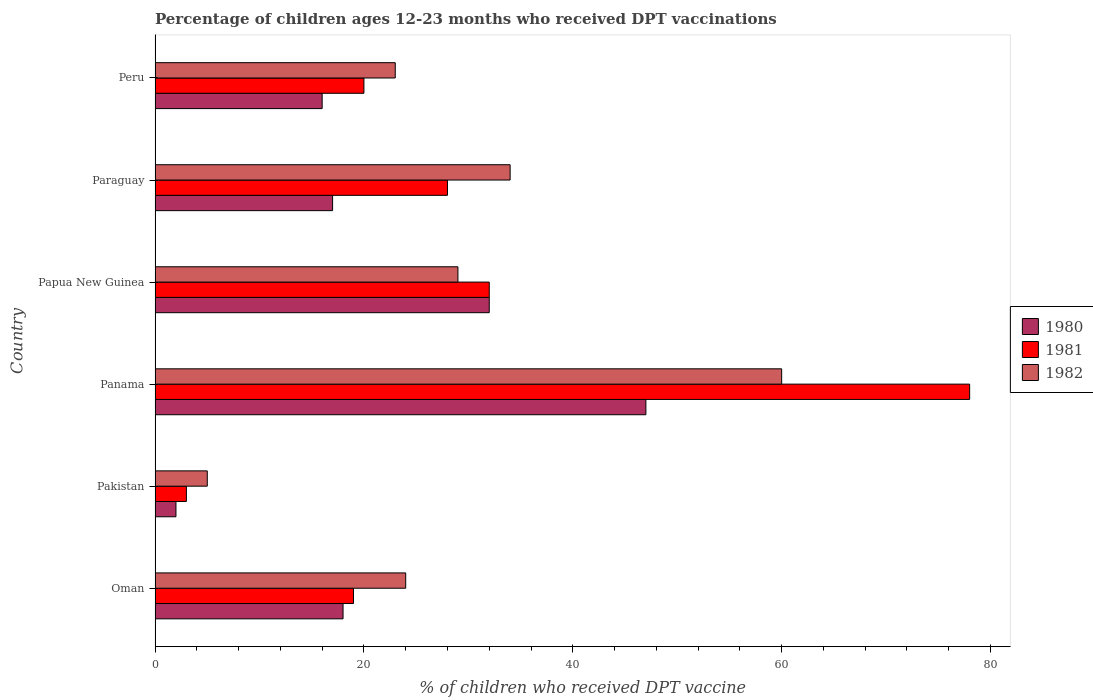How many groups of bars are there?
Provide a short and direct response. 6. Are the number of bars per tick equal to the number of legend labels?
Your answer should be compact. Yes. Are the number of bars on each tick of the Y-axis equal?
Your answer should be very brief. Yes. How many bars are there on the 4th tick from the top?
Offer a terse response. 3. What is the label of the 3rd group of bars from the top?
Give a very brief answer. Papua New Guinea. In how many cases, is the number of bars for a given country not equal to the number of legend labels?
Give a very brief answer. 0. Across all countries, what is the minimum percentage of children who received DPT vaccination in 1981?
Keep it short and to the point. 3. In which country was the percentage of children who received DPT vaccination in 1981 maximum?
Ensure brevity in your answer.  Panama. What is the total percentage of children who received DPT vaccination in 1982 in the graph?
Offer a terse response. 175. What is the difference between the percentage of children who received DPT vaccination in 1981 in Papua New Guinea and that in Peru?
Offer a very short reply. 12. In how many countries, is the percentage of children who received DPT vaccination in 1981 greater than 72 %?
Offer a very short reply. 1. What is the ratio of the percentage of children who received DPT vaccination in 1982 in Pakistan to that in Paraguay?
Your answer should be very brief. 0.15. Is the percentage of children who received DPT vaccination in 1982 in Papua New Guinea less than that in Peru?
Your response must be concise. No. Is the sum of the percentage of children who received DPT vaccination in 1981 in Oman and Peru greater than the maximum percentage of children who received DPT vaccination in 1980 across all countries?
Keep it short and to the point. No. How many countries are there in the graph?
Make the answer very short. 6. Does the graph contain any zero values?
Ensure brevity in your answer.  No. Does the graph contain grids?
Provide a short and direct response. No. How are the legend labels stacked?
Provide a short and direct response. Vertical. What is the title of the graph?
Keep it short and to the point. Percentage of children ages 12-23 months who received DPT vaccinations. Does "1986" appear as one of the legend labels in the graph?
Offer a terse response. No. What is the label or title of the X-axis?
Offer a very short reply. % of children who received DPT vaccine. What is the label or title of the Y-axis?
Ensure brevity in your answer.  Country. What is the % of children who received DPT vaccine in 1981 in Oman?
Give a very brief answer. 19. What is the % of children who received DPT vaccine of 1982 in Oman?
Ensure brevity in your answer.  24. What is the % of children who received DPT vaccine of 1980 in Pakistan?
Ensure brevity in your answer.  2. What is the % of children who received DPT vaccine in 1981 in Pakistan?
Provide a short and direct response. 3. What is the % of children who received DPT vaccine in 1981 in Panama?
Make the answer very short. 78. What is the % of children who received DPT vaccine in 1980 in Papua New Guinea?
Your response must be concise. 32. What is the % of children who received DPT vaccine in 1982 in Papua New Guinea?
Offer a terse response. 29. What is the % of children who received DPT vaccine of 1982 in Paraguay?
Ensure brevity in your answer.  34. What is the % of children who received DPT vaccine in 1981 in Peru?
Your answer should be compact. 20. Across all countries, what is the maximum % of children who received DPT vaccine in 1980?
Offer a terse response. 47. Across all countries, what is the maximum % of children who received DPT vaccine of 1982?
Give a very brief answer. 60. What is the total % of children who received DPT vaccine in 1980 in the graph?
Offer a very short reply. 132. What is the total % of children who received DPT vaccine in 1981 in the graph?
Make the answer very short. 180. What is the total % of children who received DPT vaccine of 1982 in the graph?
Give a very brief answer. 175. What is the difference between the % of children who received DPT vaccine of 1982 in Oman and that in Pakistan?
Make the answer very short. 19. What is the difference between the % of children who received DPT vaccine of 1980 in Oman and that in Panama?
Make the answer very short. -29. What is the difference between the % of children who received DPT vaccine in 1981 in Oman and that in Panama?
Ensure brevity in your answer.  -59. What is the difference between the % of children who received DPT vaccine of 1982 in Oman and that in Panama?
Offer a terse response. -36. What is the difference between the % of children who received DPT vaccine in 1981 in Oman and that in Papua New Guinea?
Offer a very short reply. -13. What is the difference between the % of children who received DPT vaccine in 1982 in Oman and that in Papua New Guinea?
Offer a terse response. -5. What is the difference between the % of children who received DPT vaccine in 1981 in Oman and that in Paraguay?
Offer a terse response. -9. What is the difference between the % of children who received DPT vaccine in 1982 in Oman and that in Paraguay?
Provide a short and direct response. -10. What is the difference between the % of children who received DPT vaccine of 1980 in Oman and that in Peru?
Make the answer very short. 2. What is the difference between the % of children who received DPT vaccine of 1981 in Oman and that in Peru?
Your answer should be compact. -1. What is the difference between the % of children who received DPT vaccine of 1980 in Pakistan and that in Panama?
Provide a succinct answer. -45. What is the difference between the % of children who received DPT vaccine in 1981 in Pakistan and that in Panama?
Make the answer very short. -75. What is the difference between the % of children who received DPT vaccine of 1982 in Pakistan and that in Panama?
Give a very brief answer. -55. What is the difference between the % of children who received DPT vaccine in 1981 in Pakistan and that in Papua New Guinea?
Your response must be concise. -29. What is the difference between the % of children who received DPT vaccine in 1982 in Pakistan and that in Papua New Guinea?
Your answer should be very brief. -24. What is the difference between the % of children who received DPT vaccine of 1980 in Pakistan and that in Paraguay?
Offer a very short reply. -15. What is the difference between the % of children who received DPT vaccine in 1981 in Pakistan and that in Paraguay?
Provide a succinct answer. -25. What is the difference between the % of children who received DPT vaccine of 1982 in Pakistan and that in Paraguay?
Your response must be concise. -29. What is the difference between the % of children who received DPT vaccine of 1982 in Pakistan and that in Peru?
Provide a short and direct response. -18. What is the difference between the % of children who received DPT vaccine in 1980 in Panama and that in Papua New Guinea?
Offer a terse response. 15. What is the difference between the % of children who received DPT vaccine of 1981 in Panama and that in Peru?
Ensure brevity in your answer.  58. What is the difference between the % of children who received DPT vaccine in 1982 in Panama and that in Peru?
Keep it short and to the point. 37. What is the difference between the % of children who received DPT vaccine in 1980 in Papua New Guinea and that in Paraguay?
Offer a very short reply. 15. What is the difference between the % of children who received DPT vaccine in 1982 in Papua New Guinea and that in Paraguay?
Give a very brief answer. -5. What is the difference between the % of children who received DPT vaccine in 1981 in Papua New Guinea and that in Peru?
Provide a succinct answer. 12. What is the difference between the % of children who received DPT vaccine of 1982 in Papua New Guinea and that in Peru?
Provide a short and direct response. 6. What is the difference between the % of children who received DPT vaccine in 1980 in Paraguay and that in Peru?
Offer a terse response. 1. What is the difference between the % of children who received DPT vaccine in 1981 in Paraguay and that in Peru?
Provide a succinct answer. 8. What is the difference between the % of children who received DPT vaccine of 1981 in Oman and the % of children who received DPT vaccine of 1982 in Pakistan?
Offer a terse response. 14. What is the difference between the % of children who received DPT vaccine of 1980 in Oman and the % of children who received DPT vaccine of 1981 in Panama?
Offer a very short reply. -60. What is the difference between the % of children who received DPT vaccine in 1980 in Oman and the % of children who received DPT vaccine in 1982 in Panama?
Your answer should be very brief. -42. What is the difference between the % of children who received DPT vaccine in 1981 in Oman and the % of children who received DPT vaccine in 1982 in Panama?
Offer a terse response. -41. What is the difference between the % of children who received DPT vaccine of 1980 in Oman and the % of children who received DPT vaccine of 1981 in Papua New Guinea?
Offer a terse response. -14. What is the difference between the % of children who received DPT vaccine in 1980 in Oman and the % of children who received DPT vaccine in 1981 in Paraguay?
Your response must be concise. -10. What is the difference between the % of children who received DPT vaccine of 1980 in Oman and the % of children who received DPT vaccine of 1982 in Paraguay?
Your answer should be very brief. -16. What is the difference between the % of children who received DPT vaccine in 1981 in Oman and the % of children who received DPT vaccine in 1982 in Paraguay?
Keep it short and to the point. -15. What is the difference between the % of children who received DPT vaccine in 1980 in Oman and the % of children who received DPT vaccine in 1982 in Peru?
Your answer should be compact. -5. What is the difference between the % of children who received DPT vaccine in 1980 in Pakistan and the % of children who received DPT vaccine in 1981 in Panama?
Offer a terse response. -76. What is the difference between the % of children who received DPT vaccine of 1980 in Pakistan and the % of children who received DPT vaccine of 1982 in Panama?
Provide a succinct answer. -58. What is the difference between the % of children who received DPT vaccine of 1981 in Pakistan and the % of children who received DPT vaccine of 1982 in Panama?
Ensure brevity in your answer.  -57. What is the difference between the % of children who received DPT vaccine of 1980 in Pakistan and the % of children who received DPT vaccine of 1981 in Papua New Guinea?
Offer a very short reply. -30. What is the difference between the % of children who received DPT vaccine of 1981 in Pakistan and the % of children who received DPT vaccine of 1982 in Papua New Guinea?
Your response must be concise. -26. What is the difference between the % of children who received DPT vaccine of 1980 in Pakistan and the % of children who received DPT vaccine of 1982 in Paraguay?
Provide a succinct answer. -32. What is the difference between the % of children who received DPT vaccine in 1981 in Pakistan and the % of children who received DPT vaccine in 1982 in Paraguay?
Offer a very short reply. -31. What is the difference between the % of children who received DPT vaccine of 1980 in Pakistan and the % of children who received DPT vaccine of 1982 in Peru?
Your answer should be very brief. -21. What is the difference between the % of children who received DPT vaccine in 1981 in Pakistan and the % of children who received DPT vaccine in 1982 in Peru?
Your answer should be compact. -20. What is the difference between the % of children who received DPT vaccine in 1981 in Panama and the % of children who received DPT vaccine in 1982 in Papua New Guinea?
Provide a short and direct response. 49. What is the difference between the % of children who received DPT vaccine of 1980 in Panama and the % of children who received DPT vaccine of 1981 in Paraguay?
Offer a very short reply. 19. What is the difference between the % of children who received DPT vaccine in 1980 in Panama and the % of children who received DPT vaccine in 1982 in Paraguay?
Keep it short and to the point. 13. What is the difference between the % of children who received DPT vaccine in 1981 in Panama and the % of children who received DPT vaccine in 1982 in Paraguay?
Offer a terse response. 44. What is the difference between the % of children who received DPT vaccine in 1980 in Panama and the % of children who received DPT vaccine in 1981 in Peru?
Keep it short and to the point. 27. What is the difference between the % of children who received DPT vaccine of 1980 in Panama and the % of children who received DPT vaccine of 1982 in Peru?
Offer a very short reply. 24. What is the difference between the % of children who received DPT vaccine in 1980 in Papua New Guinea and the % of children who received DPT vaccine in 1981 in Paraguay?
Your answer should be very brief. 4. What is the difference between the % of children who received DPT vaccine in 1981 in Papua New Guinea and the % of children who received DPT vaccine in 1982 in Paraguay?
Your answer should be very brief. -2. What is the difference between the % of children who received DPT vaccine in 1981 in Papua New Guinea and the % of children who received DPT vaccine in 1982 in Peru?
Offer a very short reply. 9. What is the difference between the % of children who received DPT vaccine of 1980 in Paraguay and the % of children who received DPT vaccine of 1982 in Peru?
Ensure brevity in your answer.  -6. What is the difference between the % of children who received DPT vaccine in 1981 in Paraguay and the % of children who received DPT vaccine in 1982 in Peru?
Give a very brief answer. 5. What is the average % of children who received DPT vaccine of 1980 per country?
Your response must be concise. 22. What is the average % of children who received DPT vaccine of 1981 per country?
Your answer should be compact. 30. What is the average % of children who received DPT vaccine in 1982 per country?
Make the answer very short. 29.17. What is the difference between the % of children who received DPT vaccine in 1980 and % of children who received DPT vaccine in 1981 in Oman?
Give a very brief answer. -1. What is the difference between the % of children who received DPT vaccine of 1981 and % of children who received DPT vaccine of 1982 in Oman?
Give a very brief answer. -5. What is the difference between the % of children who received DPT vaccine in 1980 and % of children who received DPT vaccine in 1982 in Pakistan?
Offer a terse response. -3. What is the difference between the % of children who received DPT vaccine of 1980 and % of children who received DPT vaccine of 1981 in Panama?
Provide a short and direct response. -31. What is the difference between the % of children who received DPT vaccine of 1980 and % of children who received DPT vaccine of 1981 in Papua New Guinea?
Provide a short and direct response. 0. What is the difference between the % of children who received DPT vaccine in 1980 and % of children who received DPT vaccine in 1982 in Papua New Guinea?
Ensure brevity in your answer.  3. What is the difference between the % of children who received DPT vaccine of 1981 and % of children who received DPT vaccine of 1982 in Papua New Guinea?
Offer a terse response. 3. What is the difference between the % of children who received DPT vaccine of 1980 and % of children who received DPT vaccine of 1981 in Paraguay?
Your response must be concise. -11. What is the difference between the % of children who received DPT vaccine in 1981 and % of children who received DPT vaccine in 1982 in Paraguay?
Give a very brief answer. -6. What is the difference between the % of children who received DPT vaccine of 1980 and % of children who received DPT vaccine of 1981 in Peru?
Make the answer very short. -4. What is the difference between the % of children who received DPT vaccine in 1981 and % of children who received DPT vaccine in 1982 in Peru?
Offer a very short reply. -3. What is the ratio of the % of children who received DPT vaccine in 1981 in Oman to that in Pakistan?
Make the answer very short. 6.33. What is the ratio of the % of children who received DPT vaccine of 1982 in Oman to that in Pakistan?
Your response must be concise. 4.8. What is the ratio of the % of children who received DPT vaccine of 1980 in Oman to that in Panama?
Provide a succinct answer. 0.38. What is the ratio of the % of children who received DPT vaccine of 1981 in Oman to that in Panama?
Your response must be concise. 0.24. What is the ratio of the % of children who received DPT vaccine in 1982 in Oman to that in Panama?
Make the answer very short. 0.4. What is the ratio of the % of children who received DPT vaccine of 1980 in Oman to that in Papua New Guinea?
Offer a terse response. 0.56. What is the ratio of the % of children who received DPT vaccine in 1981 in Oman to that in Papua New Guinea?
Your answer should be very brief. 0.59. What is the ratio of the % of children who received DPT vaccine in 1982 in Oman to that in Papua New Guinea?
Provide a succinct answer. 0.83. What is the ratio of the % of children who received DPT vaccine in 1980 in Oman to that in Paraguay?
Offer a terse response. 1.06. What is the ratio of the % of children who received DPT vaccine of 1981 in Oman to that in Paraguay?
Your response must be concise. 0.68. What is the ratio of the % of children who received DPT vaccine of 1982 in Oman to that in Paraguay?
Provide a short and direct response. 0.71. What is the ratio of the % of children who received DPT vaccine in 1980 in Oman to that in Peru?
Ensure brevity in your answer.  1.12. What is the ratio of the % of children who received DPT vaccine in 1981 in Oman to that in Peru?
Provide a short and direct response. 0.95. What is the ratio of the % of children who received DPT vaccine of 1982 in Oman to that in Peru?
Your answer should be compact. 1.04. What is the ratio of the % of children who received DPT vaccine in 1980 in Pakistan to that in Panama?
Your answer should be compact. 0.04. What is the ratio of the % of children who received DPT vaccine of 1981 in Pakistan to that in Panama?
Ensure brevity in your answer.  0.04. What is the ratio of the % of children who received DPT vaccine in 1982 in Pakistan to that in Panama?
Provide a short and direct response. 0.08. What is the ratio of the % of children who received DPT vaccine of 1980 in Pakistan to that in Papua New Guinea?
Ensure brevity in your answer.  0.06. What is the ratio of the % of children who received DPT vaccine in 1981 in Pakistan to that in Papua New Guinea?
Provide a succinct answer. 0.09. What is the ratio of the % of children who received DPT vaccine of 1982 in Pakistan to that in Papua New Guinea?
Offer a terse response. 0.17. What is the ratio of the % of children who received DPT vaccine in 1980 in Pakistan to that in Paraguay?
Keep it short and to the point. 0.12. What is the ratio of the % of children who received DPT vaccine in 1981 in Pakistan to that in Paraguay?
Your answer should be very brief. 0.11. What is the ratio of the % of children who received DPT vaccine in 1982 in Pakistan to that in Paraguay?
Your answer should be compact. 0.15. What is the ratio of the % of children who received DPT vaccine in 1982 in Pakistan to that in Peru?
Keep it short and to the point. 0.22. What is the ratio of the % of children who received DPT vaccine in 1980 in Panama to that in Papua New Guinea?
Offer a very short reply. 1.47. What is the ratio of the % of children who received DPT vaccine of 1981 in Panama to that in Papua New Guinea?
Provide a short and direct response. 2.44. What is the ratio of the % of children who received DPT vaccine in 1982 in Panama to that in Papua New Guinea?
Keep it short and to the point. 2.07. What is the ratio of the % of children who received DPT vaccine in 1980 in Panama to that in Paraguay?
Keep it short and to the point. 2.76. What is the ratio of the % of children who received DPT vaccine of 1981 in Panama to that in Paraguay?
Offer a very short reply. 2.79. What is the ratio of the % of children who received DPT vaccine in 1982 in Panama to that in Paraguay?
Provide a succinct answer. 1.76. What is the ratio of the % of children who received DPT vaccine of 1980 in Panama to that in Peru?
Provide a short and direct response. 2.94. What is the ratio of the % of children who received DPT vaccine of 1982 in Panama to that in Peru?
Give a very brief answer. 2.61. What is the ratio of the % of children who received DPT vaccine in 1980 in Papua New Guinea to that in Paraguay?
Make the answer very short. 1.88. What is the ratio of the % of children who received DPT vaccine in 1982 in Papua New Guinea to that in Paraguay?
Ensure brevity in your answer.  0.85. What is the ratio of the % of children who received DPT vaccine of 1982 in Papua New Guinea to that in Peru?
Ensure brevity in your answer.  1.26. What is the ratio of the % of children who received DPT vaccine of 1980 in Paraguay to that in Peru?
Provide a succinct answer. 1.06. What is the ratio of the % of children who received DPT vaccine in 1981 in Paraguay to that in Peru?
Your answer should be compact. 1.4. What is the ratio of the % of children who received DPT vaccine of 1982 in Paraguay to that in Peru?
Provide a short and direct response. 1.48. What is the difference between the highest and the second highest % of children who received DPT vaccine of 1981?
Offer a very short reply. 46. What is the difference between the highest and the lowest % of children who received DPT vaccine of 1980?
Give a very brief answer. 45. What is the difference between the highest and the lowest % of children who received DPT vaccine in 1981?
Your response must be concise. 75. What is the difference between the highest and the lowest % of children who received DPT vaccine in 1982?
Provide a succinct answer. 55. 